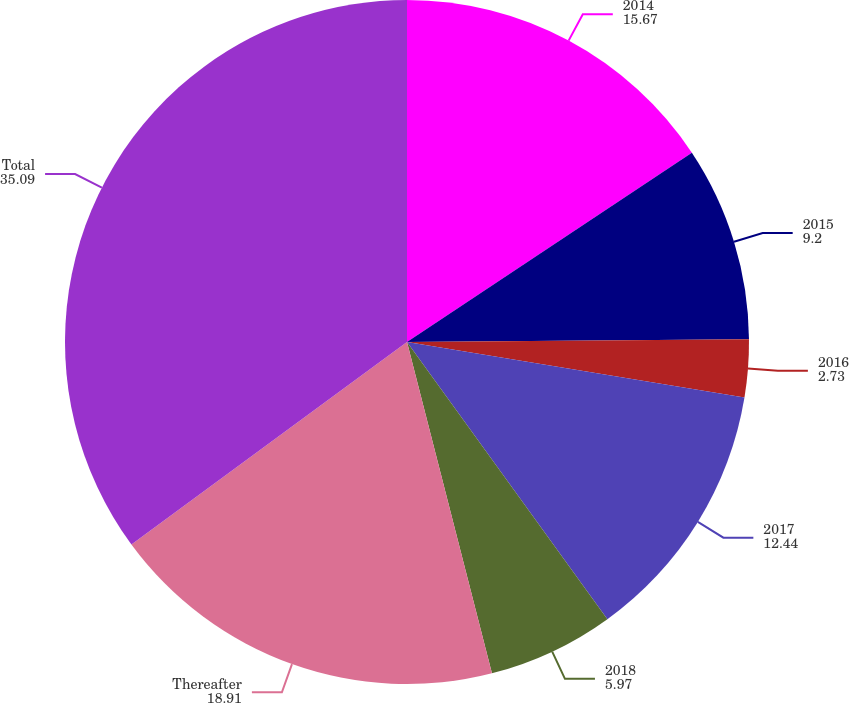<chart> <loc_0><loc_0><loc_500><loc_500><pie_chart><fcel>2014<fcel>2015<fcel>2016<fcel>2017<fcel>2018<fcel>Thereafter<fcel>Total<nl><fcel>15.67%<fcel>9.2%<fcel>2.73%<fcel>12.44%<fcel>5.97%<fcel>18.91%<fcel>35.09%<nl></chart> 